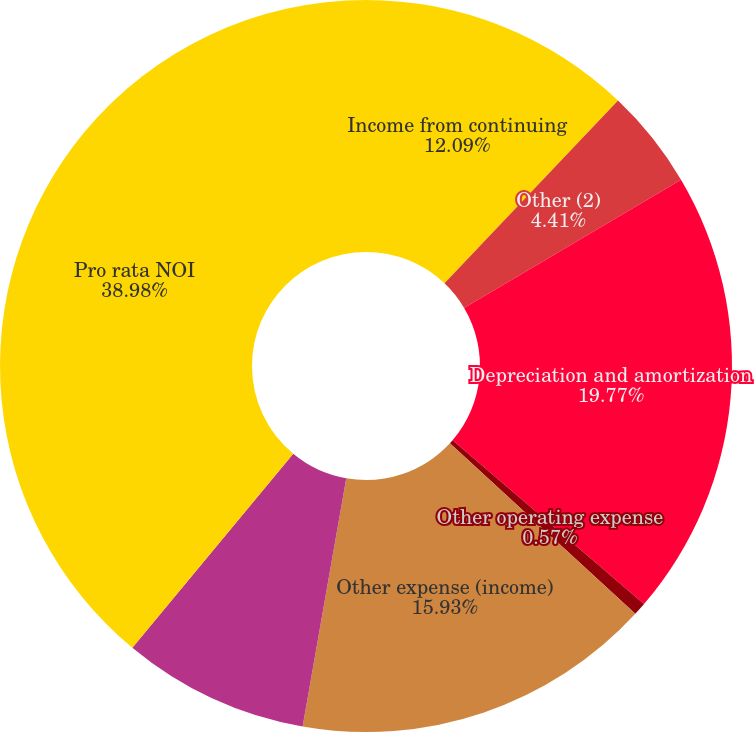Convert chart. <chart><loc_0><loc_0><loc_500><loc_500><pie_chart><fcel>Income from continuing<fcel>Other (2)<fcel>Depreciation and amortization<fcel>Other operating expense<fcel>Other expense (income)<fcel>Equity in income (loss) of<fcel>Pro rata NOI<nl><fcel>12.09%<fcel>4.41%<fcel>19.77%<fcel>0.57%<fcel>15.93%<fcel>8.25%<fcel>38.98%<nl></chart> 